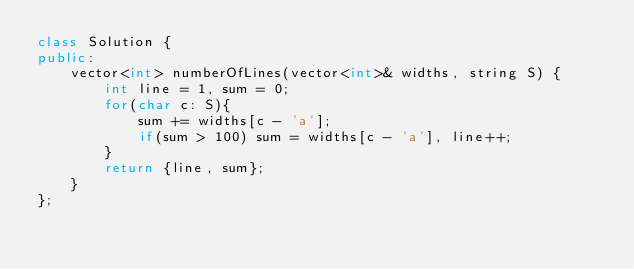<code> <loc_0><loc_0><loc_500><loc_500><_C++_>class Solution {
public:
    vector<int> numberOfLines(vector<int>& widths, string S) {
        int line = 1, sum = 0;
        for(char c: S){
            sum += widths[c - 'a'];
            if(sum > 100) sum = widths[c - 'a'], line++;
        }
        return {line, sum};
    }
};
</code> 